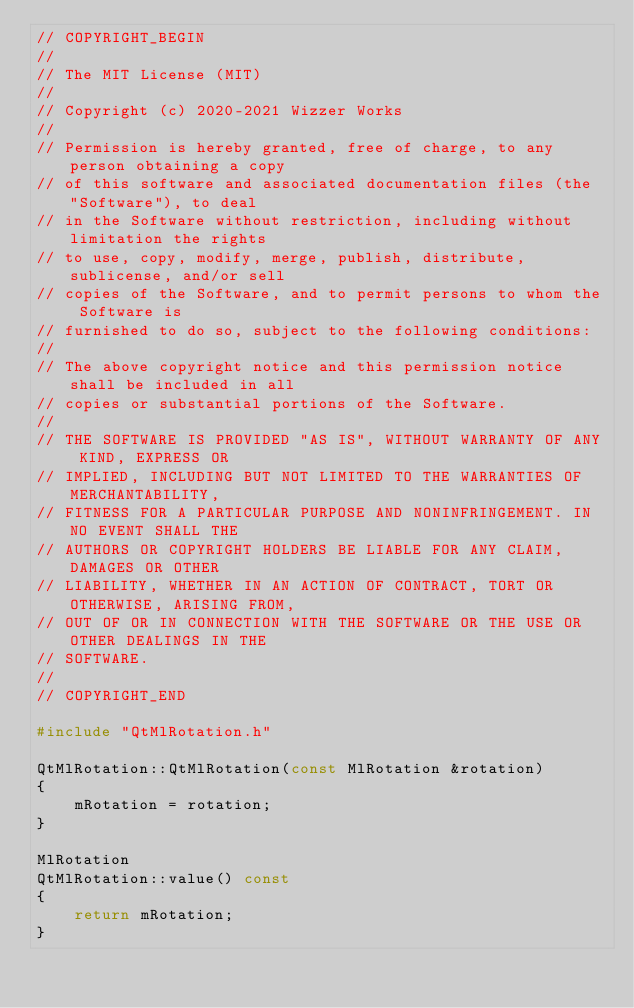Convert code to text. <code><loc_0><loc_0><loc_500><loc_500><_C++_>// COPYRIGHT_BEGIN
//
// The MIT License (MIT)
//
// Copyright (c) 2020-2021 Wizzer Works
//
// Permission is hereby granted, free of charge, to any person obtaining a copy
// of this software and associated documentation files (the "Software"), to deal
// in the Software without restriction, including without limitation the rights
// to use, copy, modify, merge, publish, distribute, sublicense, and/or sell
// copies of the Software, and to permit persons to whom the Software is
// furnished to do so, subject to the following conditions:
//
// The above copyright notice and this permission notice shall be included in all
// copies or substantial portions of the Software.
//
// THE SOFTWARE IS PROVIDED "AS IS", WITHOUT WARRANTY OF ANY KIND, EXPRESS OR
// IMPLIED, INCLUDING BUT NOT LIMITED TO THE WARRANTIES OF MERCHANTABILITY,
// FITNESS FOR A PARTICULAR PURPOSE AND NONINFRINGEMENT. IN NO EVENT SHALL THE
// AUTHORS OR COPYRIGHT HOLDERS BE LIABLE FOR ANY CLAIM, DAMAGES OR OTHER
// LIABILITY, WHETHER IN AN ACTION OF CONTRACT, TORT OR OTHERWISE, ARISING FROM,
// OUT OF OR IN CONNECTION WITH THE SOFTWARE OR THE USE OR OTHER DEALINGS IN THE
// SOFTWARE.
//
// COPYRIGHT_END

#include "QtMlRotation.h"

QtMlRotation::QtMlRotation(const MlRotation &rotation)
{
    mRotation = rotation;
}

MlRotation
QtMlRotation::value() const
{
    return mRotation;
}
</code> 